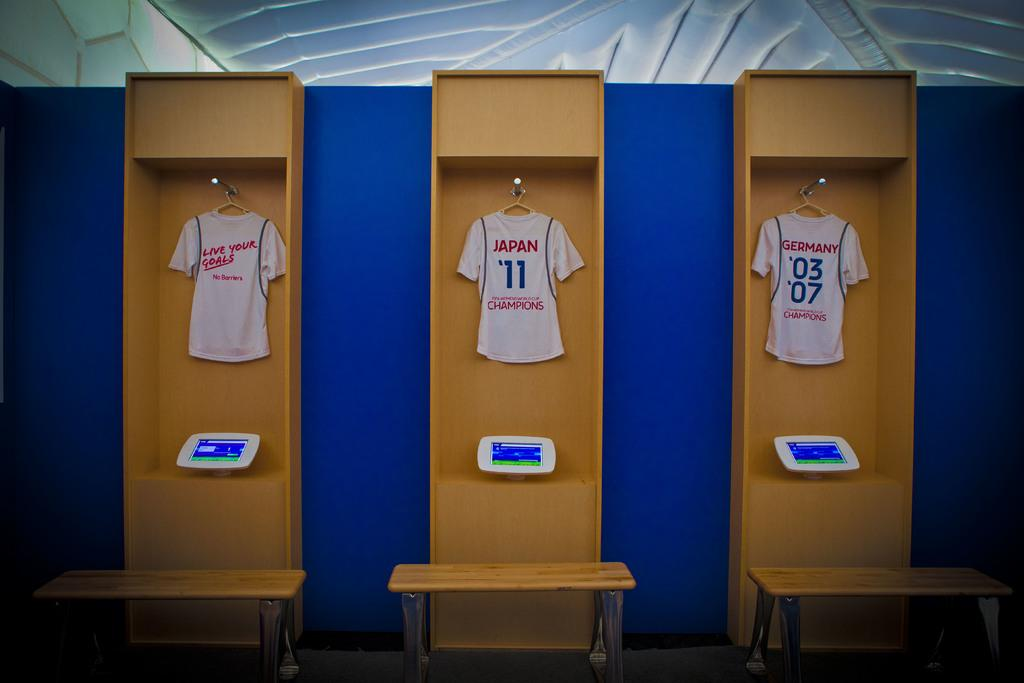<image>
Give a short and clear explanation of the subsequent image. Change room locker with soccer jerseys from Germany and Japan. 